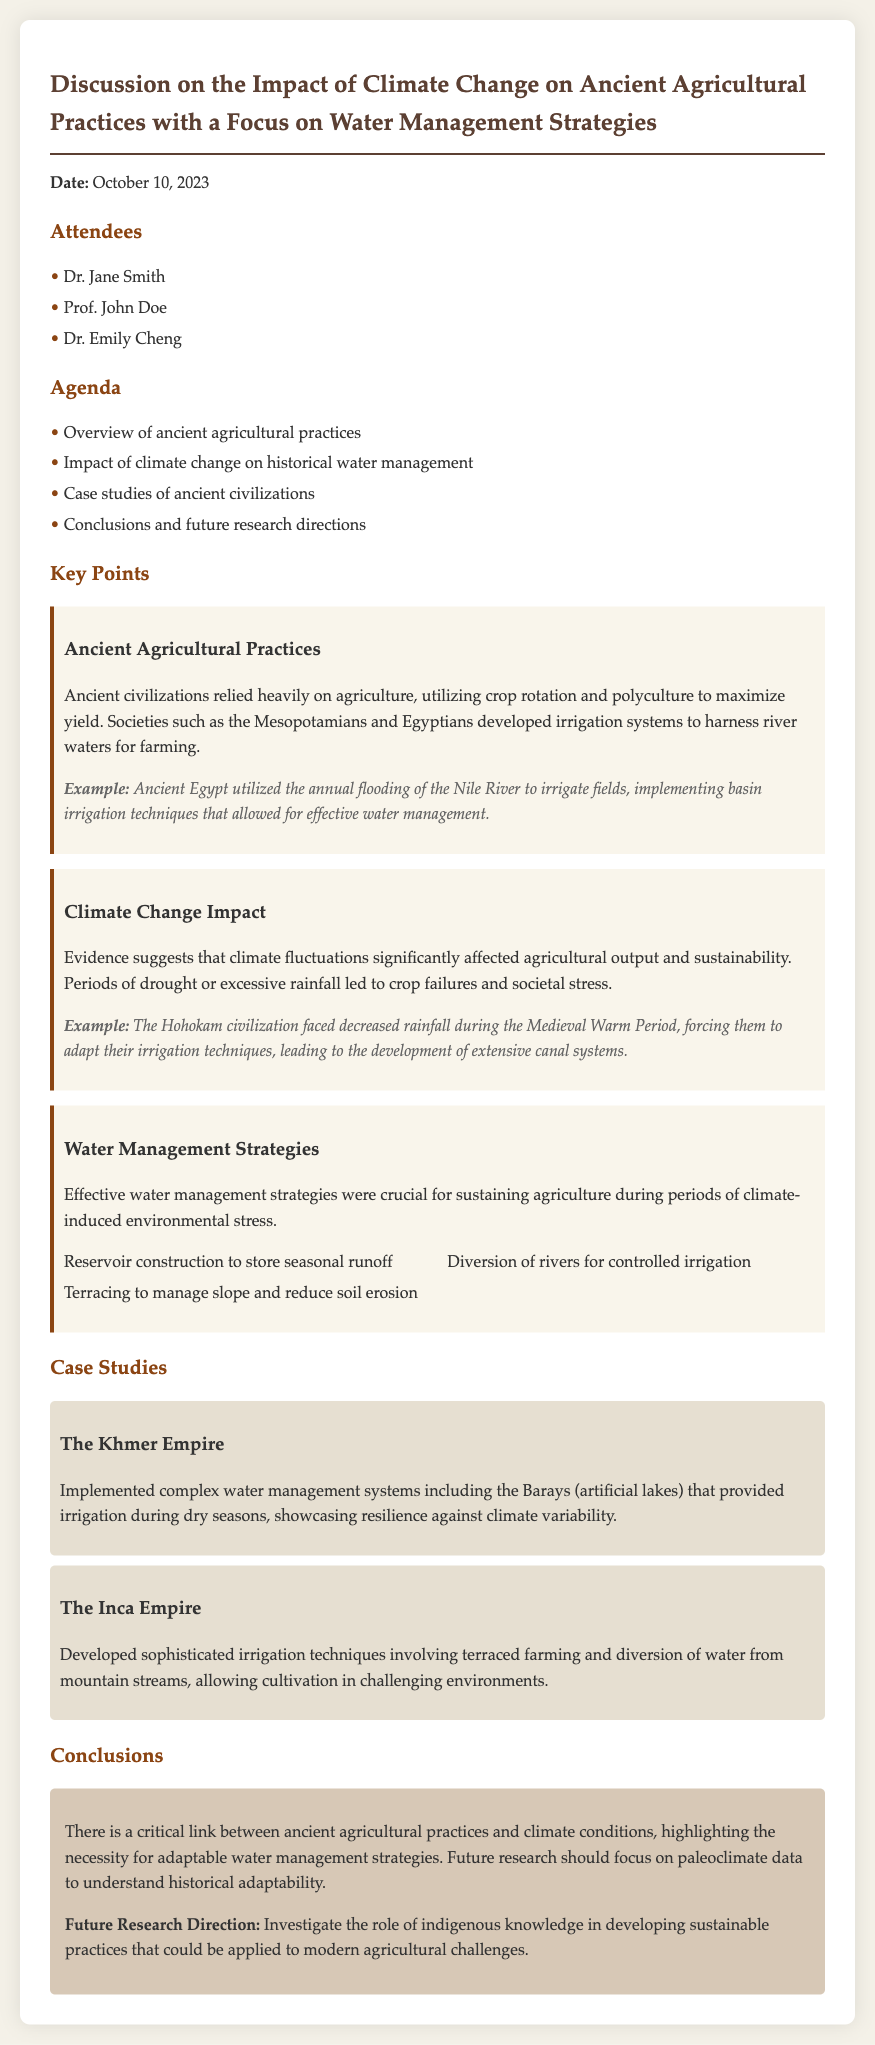What date was the meeting held? The date of the meeting is explicitly stated at the top of the document.
Answer: October 10, 2023 Who are the attendees listed in the document? The attendees are listed under the "Attendees" section, providing names of participants.
Answer: Dr. Jane Smith, Prof. John Doe, Dr. Emily Cheng What focus area does this meeting discuss? The title of the document indicates the main topic of discussion during the meeting.
Answer: Climate Change Impact on Ancient Agriculture Which ancient civilization implemented the Barays? The case studies section specifies various civilizations and their practices related to water management.
Answer: The Khmer Empire What water management strategy is mentioned for the Inca Empire? The case study of the Inca Empire identifies their specific irrigation techniques related to water management.
Answer: Terraced farming How did the Hohokam civilization adapt during the Medieval Warm Period? The climate change impact section provides an example illustrating their response to environmental stress.
Answer: Developed extensive canal systems What was one of the future research directions mentioned? The conclusions section outlines future research directions to be pursued, indicating specific areas of interest for further study.
Answer: Investigate the role of indigenous knowledge What is one key water management technique listed in the document? The techniques described under the water management strategies highlight various methods utilized by ancient civilizations.
Answer: Reservoir construction to store seasonal runoff 